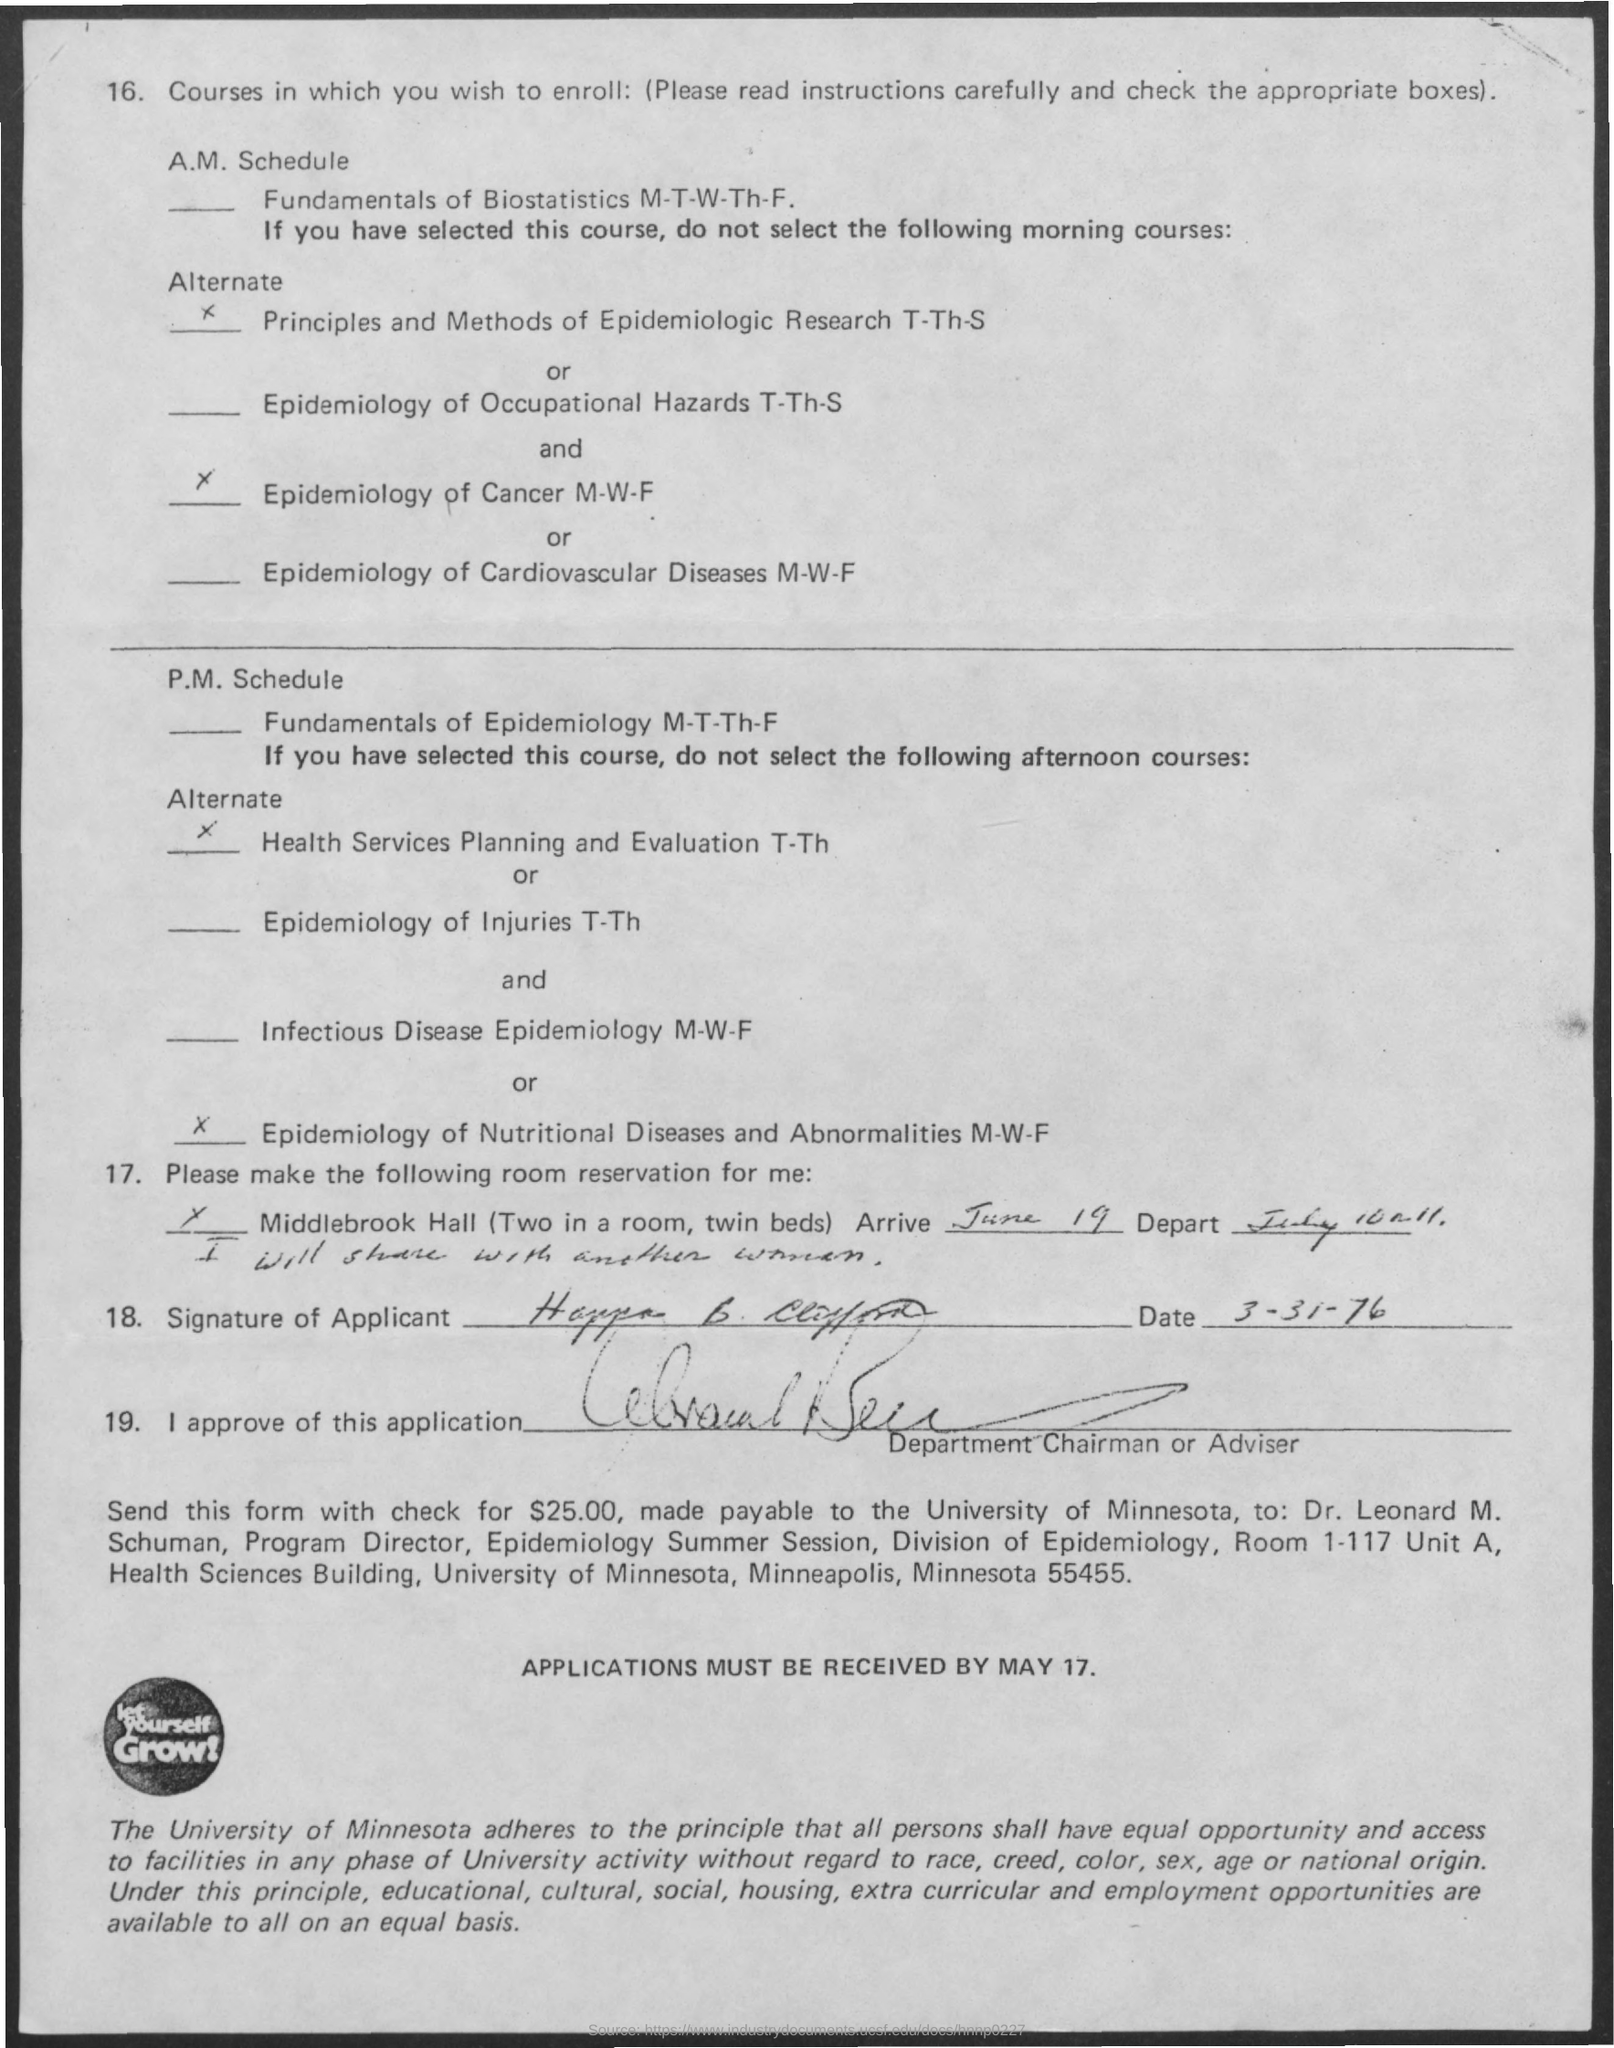Identify some key points in this picture. Applications must be received by May 17th. The date on which the applicant signed the application is March 31, 1976. Let yourself grow by revealing the written content in the logo located at the bottom of the document. The University of Minnesota is mentioned in the last paragraph of the passage. 